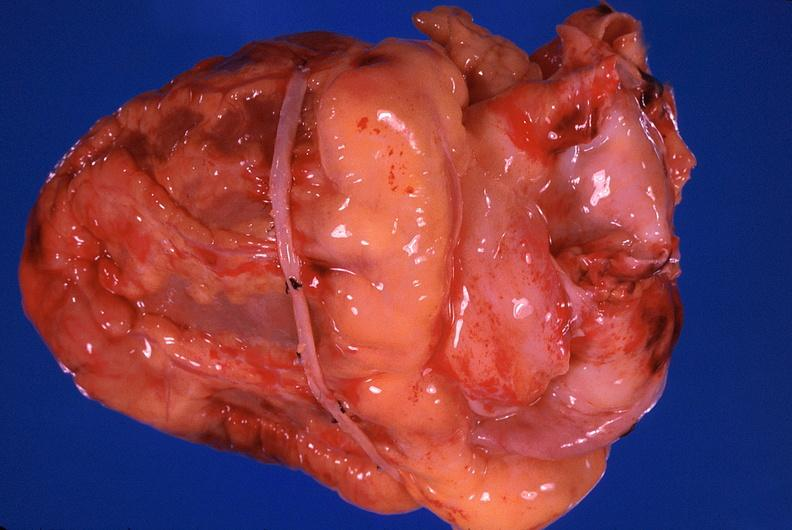what does this image show?
Answer the question using a single word or phrase. Heart 